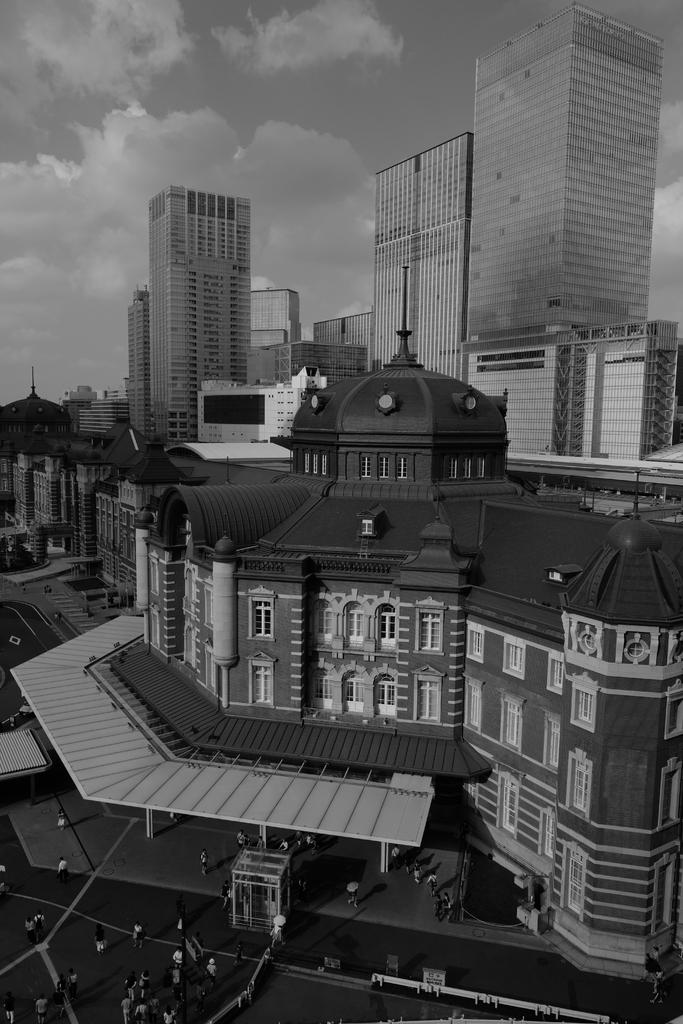What are the people in the image wearing? There are people with dresses in the image. What can be seen in the distance behind the people? There are buildings in the background of the image. What type of natural elements can be seen in the background? There are clouds visible in the background of the image. What else is visible in the background of the image? The sky is visible in the background of the image. What is the price of the tub in the image? There is no tub present in the image, so it is not possible to determine its price. 